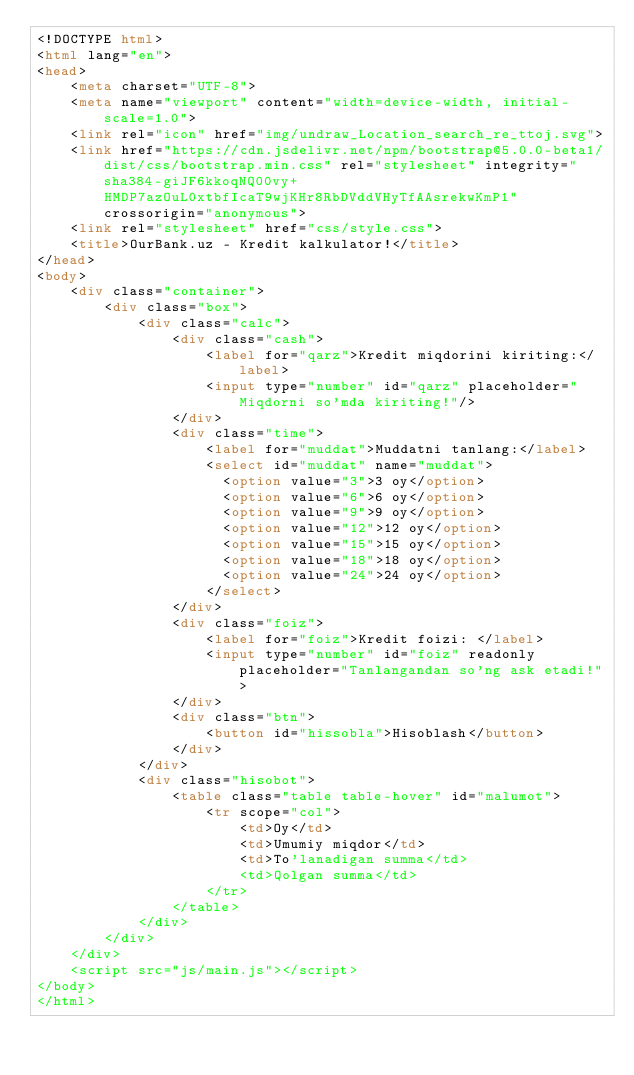Convert code to text. <code><loc_0><loc_0><loc_500><loc_500><_HTML_><!DOCTYPE html>
<html lang="en">
<head>
    <meta charset="UTF-8">
    <meta name="viewport" content="width=device-width, initial-scale=1.0">
    <link rel="icon" href="img/undraw_Location_search_re_ttoj.svg">
    <link href="https://cdn.jsdelivr.net/npm/bootstrap@5.0.0-beta1/dist/css/bootstrap.min.css" rel="stylesheet" integrity="sha384-giJF6kkoqNQ00vy+HMDP7azOuL0xtbfIcaT9wjKHr8RbDVddVHyTfAAsrekwKmP1" crossorigin="anonymous">
    <link rel="stylesheet" href="css/style.css">
    <title>OurBank.uz - Kredit kalkulator!</title>
</head>
<body>
    <div class="container">
        <div class="box">
            <div class="calc">
                <div class="cash">
                    <label for="qarz">Kredit miqdorini kiriting:</label>
                    <input type="number" id="qarz" placeholder="Miqdorni so'mda kiriting!"/>
                </div>
                <div class="time">
                    <label for="muddat">Muddatni tanlang:</label>
                    <select id="muddat" name="muddat">
                      <option value="3">3 oy</option>
                      <option value="6">6 oy</option>
                      <option value="9">9 oy</option>
                      <option value="12">12 oy</option>
                      <option value="15">15 oy</option>
                      <option value="18">18 oy</option>
                      <option value="24">24 oy</option>
                    </select>
                </div>
                <div class="foiz">
                    <label for="foiz">Kredit foizi: </label>
                    <input type="number" id="foiz" readonly placeholder="Tanlangandan so'ng ask etadi!">
                </div>
                <div class="btn">
                    <button id="hissobla">Hisoblash</button>
                </div>
            </div>
            <div class="hisobot">
                <table class="table table-hover" id="malumot">
                    <tr scope="col">
                        <td>Oy</td>
                        <td>Umumiy miqdor</td>
                        <td>To'lanadigan summa</td>
                        <td>Qolgan summa</td>
                    </tr>
                </table>
            </div>
        </div>
    </div>
    <script src="js/main.js"></script>
</body>
</html></code> 